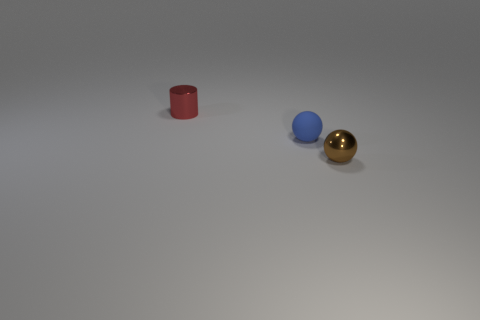Add 2 brown things. How many objects exist? 5 Subtract all brown balls. How many balls are left? 1 Add 1 small brown spheres. How many small brown spheres are left? 2 Add 1 blue things. How many blue things exist? 2 Subtract 1 red cylinders. How many objects are left? 2 Subtract all balls. How many objects are left? 1 Subtract 1 balls. How many balls are left? 1 Subtract all gray cylinders. Subtract all cyan cubes. How many cylinders are left? 1 Subtract all brown cylinders. How many green balls are left? 0 Subtract all matte objects. Subtract all blue things. How many objects are left? 1 